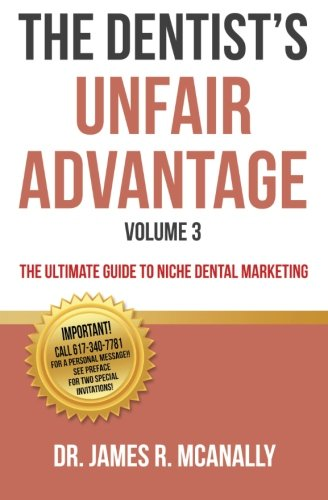Can you tell me what special offers are mentioned on the cover of this book? The cover mentions that by calling a specific number, one can get two-for-one special opportunities for 'Professional Meeting Invitations.' 